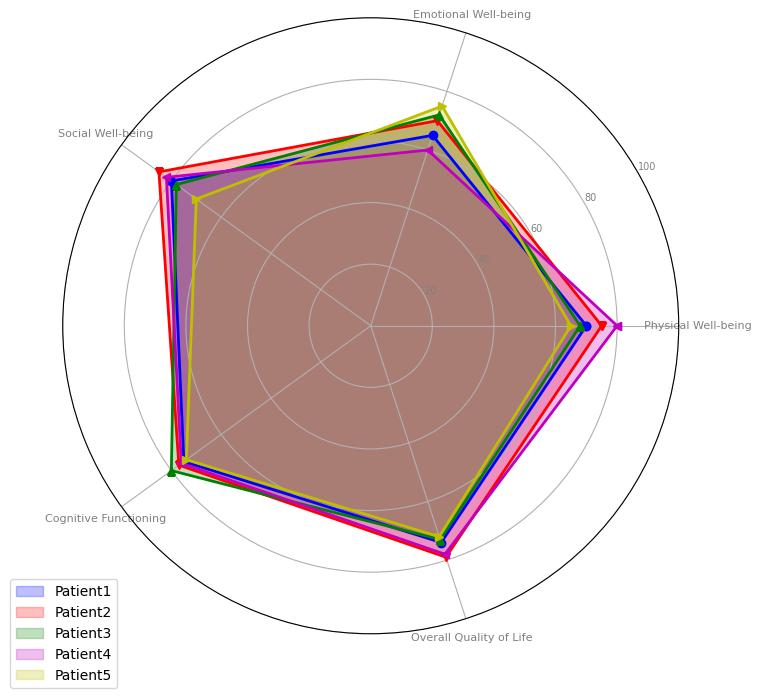What is the highest score for Social Well-being? Look at the Social Well-being category on the radar chart and identify the highest value among the patients. The scores are 80, 85, 78, 82, and 70. The highest score is 85 for Patient 2.
Answer: 85 Which patient has the lowest score for Emotional Well-being? Check the Emotional Well-being category on the radar chart and compare the scores for each patient. The scores are 65, 70, 72, 60, and 75. The lowest score is 60 for Patient 4.
Answer: Patient 4 What is the range of scores for Physical Well-being? Find the minimum and maximum values in the Physical Well-being category. The scores are 70, 75, 68, 80, and 65. The range is calculated as the difference between the maximum (80) and the minimum (65) scores.
Answer: 15 Which two patients have the closest scores for Cognitive Functioning? Compare the scores under the Cognitive Functioning category to find the two patients with the smallest difference. The scores are 75, 77, 80, 76, and 74. The smallest difference is between Patient 1 (75) and Patient 5 (74), which is 1 point.
Answer: Patient 1 and Patient 5 Who scored the highest overall across the five categories? Determine the sum of scores for each patient across all five categories. The total scores are: Patient 1: (70+65+80+75+74)=364, Patient 2: (75+70+85+77+79)=386, Patient 3: (68+72+78+80+73)=371, Patient 4: (80+60+82+76+78)=376, Patient 5: (65+75+70+74+72)=356. Patient 2 has the highest overall score of 386.
Answer: Patient 2 What is the average score for Patient 3 across all categories? Sum the scores for Patient 3 and divide by the number of categories. The scores are 68, 72, 78, 80, and 73. The sum is 371. The average is 371 divided by 5, which equals 74.2.
Answer: 74.2 Which category shows the least variability in scores across all patients? Compare the range (difference between the highest and lowest scores) for each category. The ranges are: Physical Well-being: 15, Emotional Well-being: 15, Social Well-being: 15, Cognitive Functioning: 6, and Overall Quality of Life: 7. The category with the smallest range (least variability) is Cognitive Functioning.
Answer: Cognitive Functioning Between Patient 1 and Patient 4, who has better Social Well-being scores? Compare the Social Well-being scores for Patient 1 (80) and Patient 4 (82). Patient 4 has a higher score.
Answer: Patient 4 